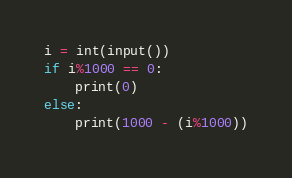Convert code to text. <code><loc_0><loc_0><loc_500><loc_500><_Python_>i = int(input())
if i%1000 == 0:
    print(0)
else:
    print(1000 - (i%1000))
</code> 